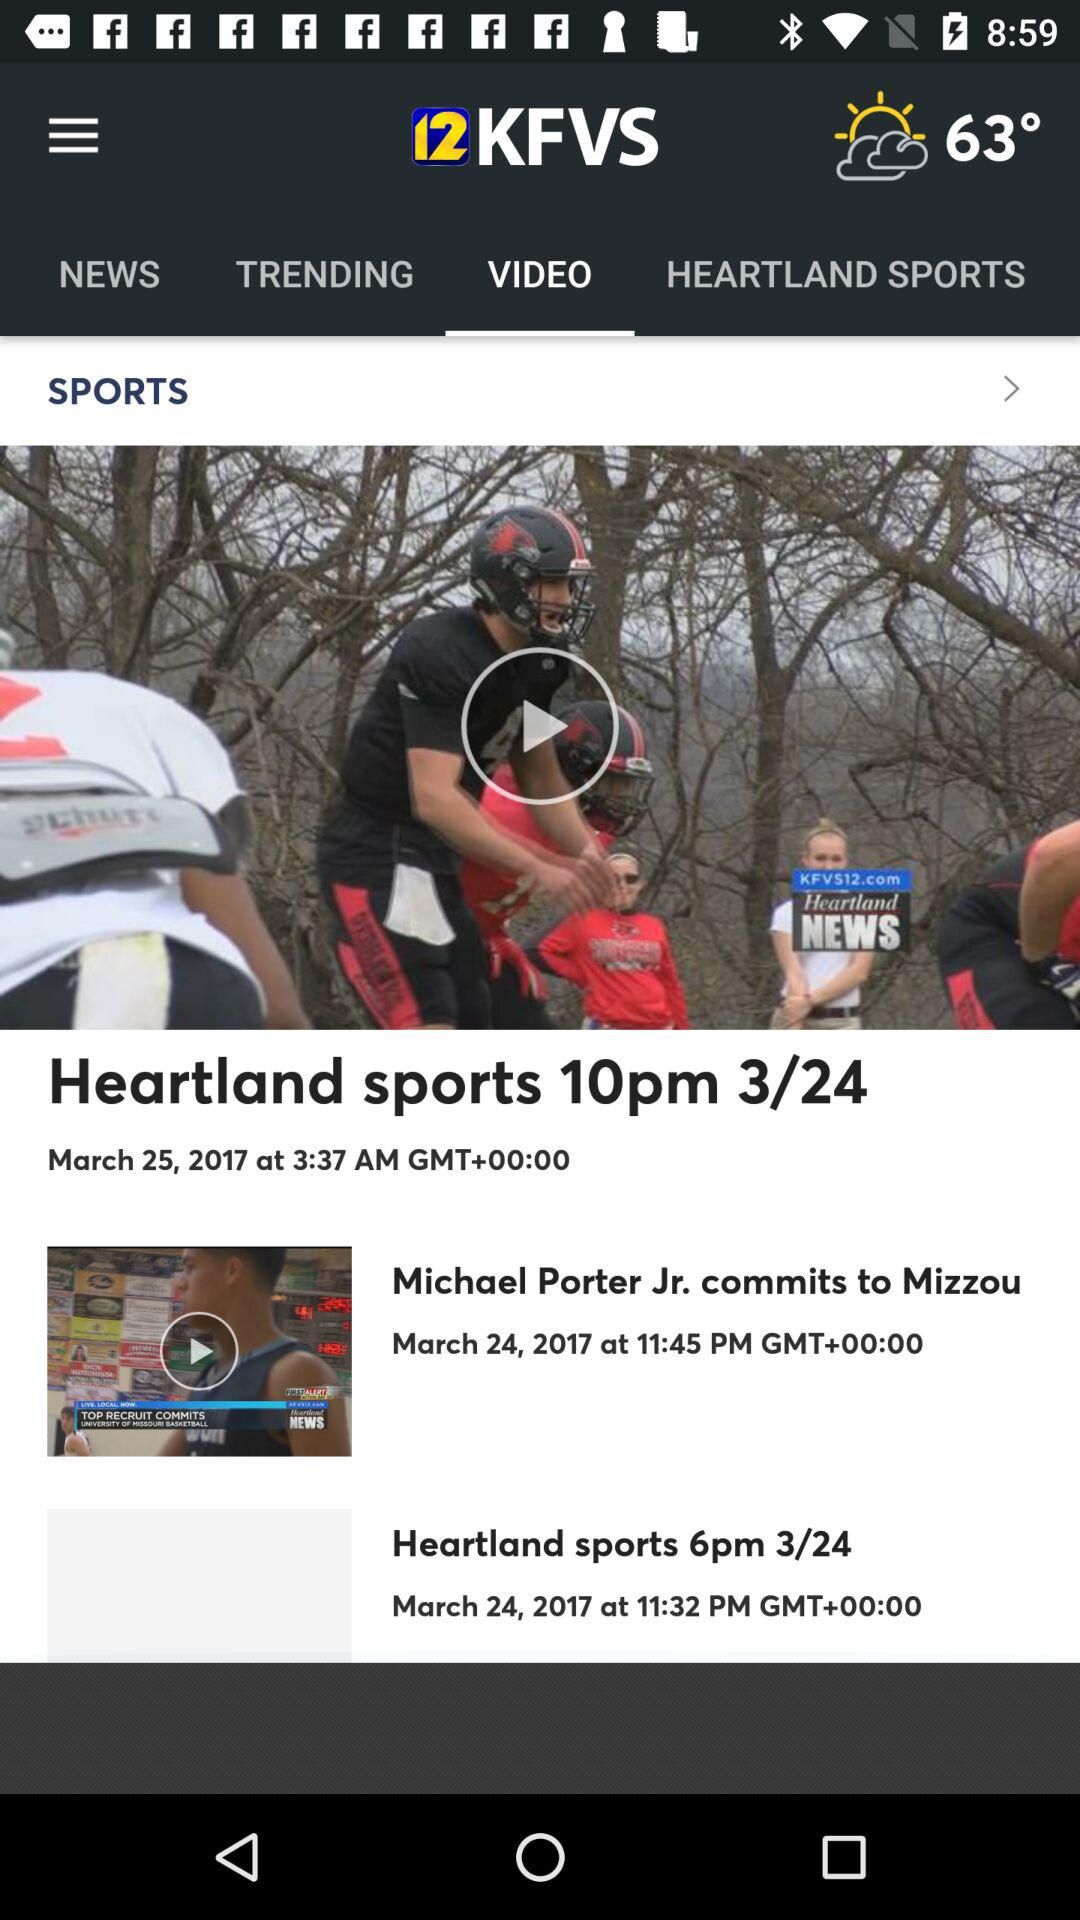What is the name of the application? The name of the application is "12 KFVS". 